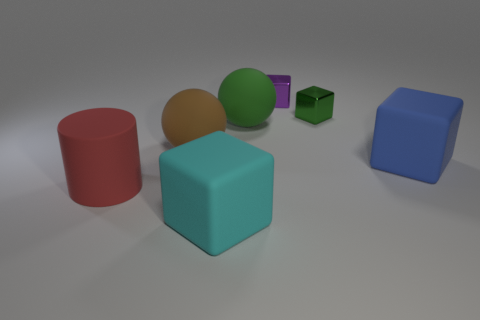Subtract 2 cubes. How many cubes are left? 2 Subtract all large cyan rubber cubes. How many cubes are left? 3 Subtract all blue blocks. How many blocks are left? 3 Add 2 large green things. How many objects exist? 9 Subtract all brown blocks. Subtract all purple balls. How many blocks are left? 4 Subtract all balls. How many objects are left? 5 Subtract all small purple rubber blocks. Subtract all purple metal objects. How many objects are left? 6 Add 4 purple things. How many purple things are left? 5 Add 2 big red metallic things. How many big red metallic things exist? 2 Subtract 1 purple cubes. How many objects are left? 6 